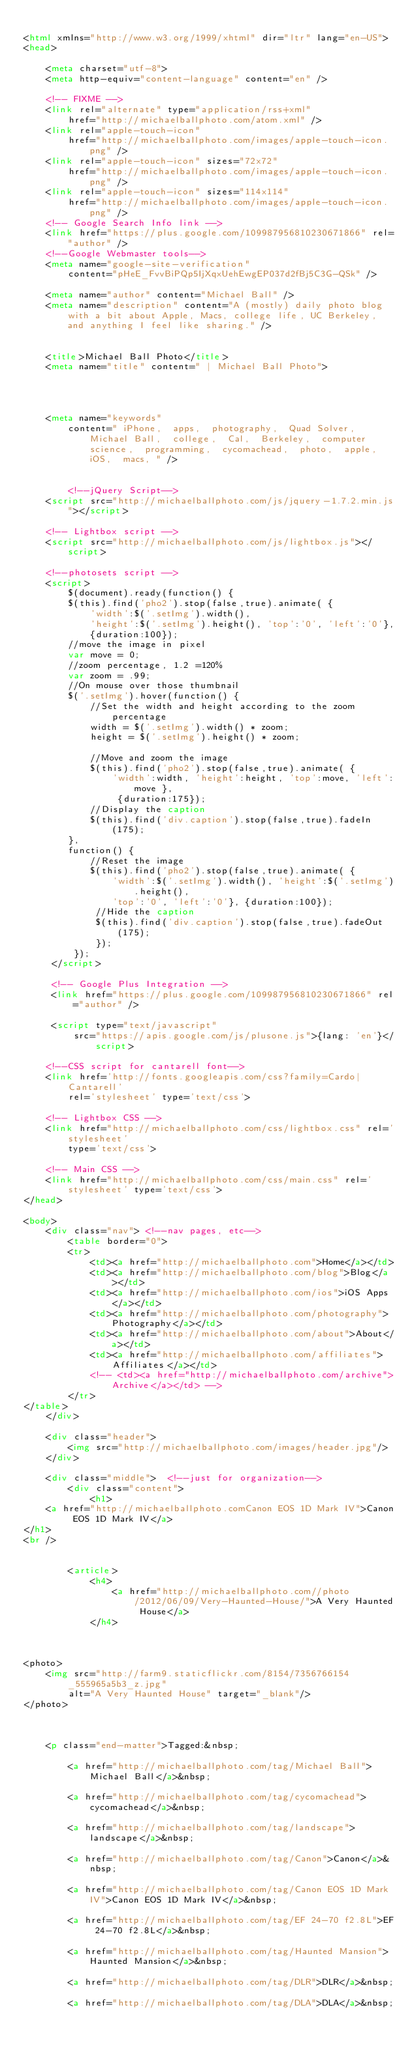<code> <loc_0><loc_0><loc_500><loc_500><_HTML_>
<html xmlns="http://www.w3.org/1999/xhtml" dir="ltr" lang="en-US">
<head>

    <meta charset="utf-8">
    <meta http-equiv="content-language" content="en" />

    <!-- FIXME -->
    <link rel="alternate" type="application/rss+xml"
        href="http://michaelballphoto.com/atom.xml" />
    <link rel="apple-touch-icon"
        href="http://michaelballphoto.com/images/apple-touch-icon.png" />
    <link rel="apple-touch-icon" sizes="72x72"
        href="http://michaelballphoto.com/images/apple-touch-icon.png" />
    <link rel="apple-touch-icon" sizes="114x114"
        href="http://michaelballphoto.com/images/apple-touch-icon.png" />
    <!-- Google Search Info link -->
    <link href="https://plus.google.com/109987956810230671866" rel="author" />
    <!--Google Webmaster tools-->
    <meta name="google-site-verification"
        content="pHeE_FvvBiPQp5IjXqxUehEwgEP037d2fBj5C3G-QSk" />

    <meta name="author" content="Michael Ball" />
    <meta name="description" content="A (mostly) daily photo blog with a bit about Apple, Macs, college life, UC Berkeley, and anything I feel like sharing." />

    
    <title>Michael Ball Photo</title>
    <meta name="title" content=" | Michael Ball Photo">
    


    
    <meta name="keywords"
        content=" iPhone,  apps,  photography,  Quad Solver,  Michael Ball,  college,  Cal,  Berkeley,  computer science,  programming,  cycomachead,  photo,  apple,  iOS,  macs, " />
    

        <!--jQuery Script-->
    <script src="http://michaelballphoto.com/js/jquery-1.7.2.min.js"></script>

    <!-- Lightbox script -->
    <script src="http://michaelballphoto.com/js/lightbox.js"></script>

    <!--photosets script -->
    <script>
        $(document).ready(function() {
        $(this).find('pho2').stop(false,true).animate( {
            'width':$('.setImg').width(),
            'height':$('.setImg').height(), 'top':'0', 'left':'0'},
            {duration:100});
        //move the image in pixel
        var move = 0;
        //zoom percentage, 1.2 =120%
        var zoom = .99;
        //On mouse over those thumbnail
        $('.setImg').hover(function() {
            //Set the width and height according to the zoom percentage
            width = $('.setImg').width() * zoom;
            height = $('.setImg').height() * zoom;

            //Move and zoom the image
            $(this).find('pho2').stop(false,true).animate( {
                'width':width, 'height':height, 'top':move, 'left':move },
                 {duration:175});
            //Display the caption
            $(this).find('div.caption').stop(false,true).fadeIn(175);
        },
        function() {
            //Reset the image
            $(this).find('pho2').stop(false,true).animate( {
                'width':$('.setImg').width(), 'height':$('.setImg').height(),
                'top':'0', 'left':'0'}, {duration:100});
             //Hide the caption
             $(this).find('div.caption').stop(false,true).fadeOut(175);
             });
         });
     </script>

     <!-- Google Plus Integration -->
     <link href="https://plus.google.com/109987956810230671866" rel="author" />

     <script type="text/javascript"
         src="https://apis.google.com/js/plusone.js">{lang: 'en'}</script>

    <!--CSS script for cantarell font-->
    <link href='http://fonts.googleapis.com/css?family=Cardo|Cantarell'
        rel='stylesheet' type='text/css'>

    <!-- Lightbox CSS -->
    <link href="http://michaelballphoto.com/css/lightbox.css" rel='stylesheet' 
        type='text/css'>

    <!-- Main CSS -->
    <link href="http://michaelballphoto.com/css/main.css" rel='stylesheet' type='text/css'>
</head>

<body>
    <div class="nav"> <!--nav pages, etc-->
        <table border="0">
        <tr>
            <td><a href="http://michaelballphoto.com">Home</a></td>
            <td><a href="http://michaelballphoto.com/blog">Blog</a></td>
            <td><a href="http://michaelballphoto.com/ios">iOS Apps</a></td>
            <td><a href="http://michaelballphoto.com/photography">Photography</a></td>
            <td><a href="http://michaelballphoto.com/about">About</a></td>
            <td><a href="http://michaelballphoto.com/affiliates">Affiliates</a></td>
            <!-- <td><a href="http://michaelballphoto.com/archive">Archive</a></td> -->
        </tr>
</table>
    </div>

    <div class="header">
        <img src="http://michaelballphoto.com/images/header.jpg"/>
    </div>

    <div class="middle">  <!--just for organization-->
        <div class="content">
            <h1>
    <a href="http://michaelballphoto.comCanon EOS 1D Mark IV">Canon EOS 1D Mark IV</a>
</h1>
<br />


        <article>
            <h4>
                <a href="http://michaelballphoto.com//photo/2012/06/09/Very-Haunted-House/">A Very Haunted House</a>
            </h4>
            
                

<photo>
    <img src="http://farm9.staticflickr.com/8154/7356766154_555965a5b3_z.jpg"
        alt="A Very Haunted House" target="_blank"/>
</photo>
            
            

    <p class="end-matter">Tagged:&nbsp;
        
        <a href="http://michaelballphoto.com/tag/Michael Ball">Michael Ball</a>&nbsp;
        
        <a href="http://michaelballphoto.com/tag/cycomachead">cycomachead</a>&nbsp;
        
        <a href="http://michaelballphoto.com/tag/landscape">landscape</a>&nbsp;
        
        <a href="http://michaelballphoto.com/tag/Canon">Canon</a>&nbsp;
        
        <a href="http://michaelballphoto.com/tag/Canon EOS 1D Mark IV">Canon EOS 1D Mark IV</a>&nbsp;
        
        <a href="http://michaelballphoto.com/tag/EF 24-70 f2.8L">EF 24-70 f2.8L</a>&nbsp;
        
        <a href="http://michaelballphoto.com/tag/Haunted Mansion">Haunted Mansion</a>&nbsp;
        
        <a href="http://michaelballphoto.com/tag/DLR">DLR</a>&nbsp;
        
        <a href="http://michaelballphoto.com/tag/DLA">DLA</a>&nbsp;
        </code> 